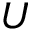Convert formula to latex. <formula><loc_0><loc_0><loc_500><loc_500>U</formula> 